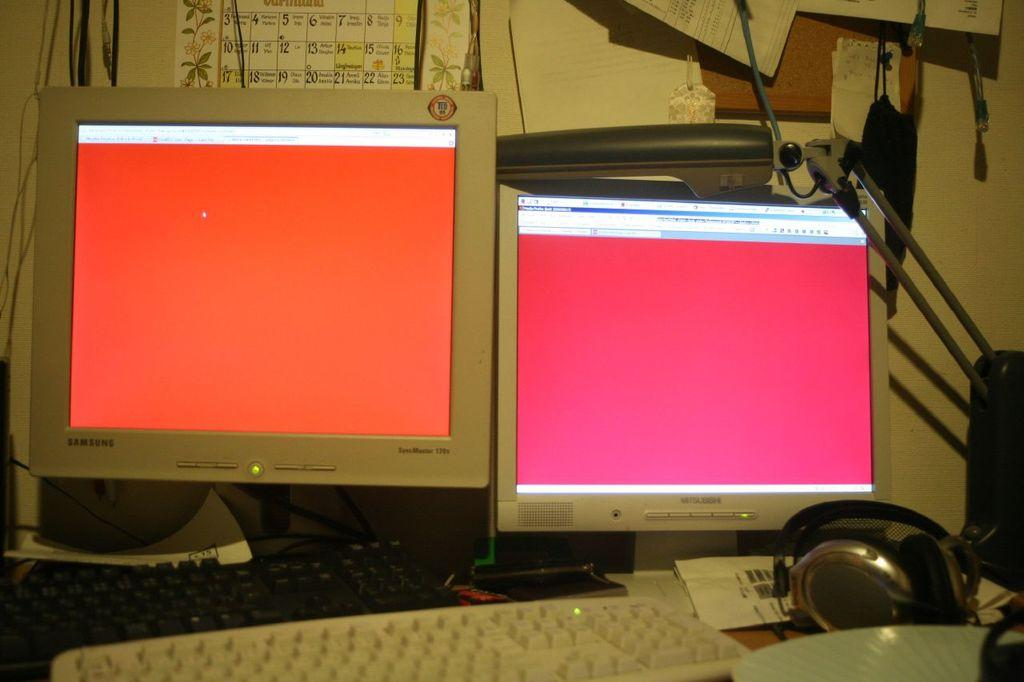<image>
Provide a brief description of the given image. Two computer screns with one being a Samsung branded one. 